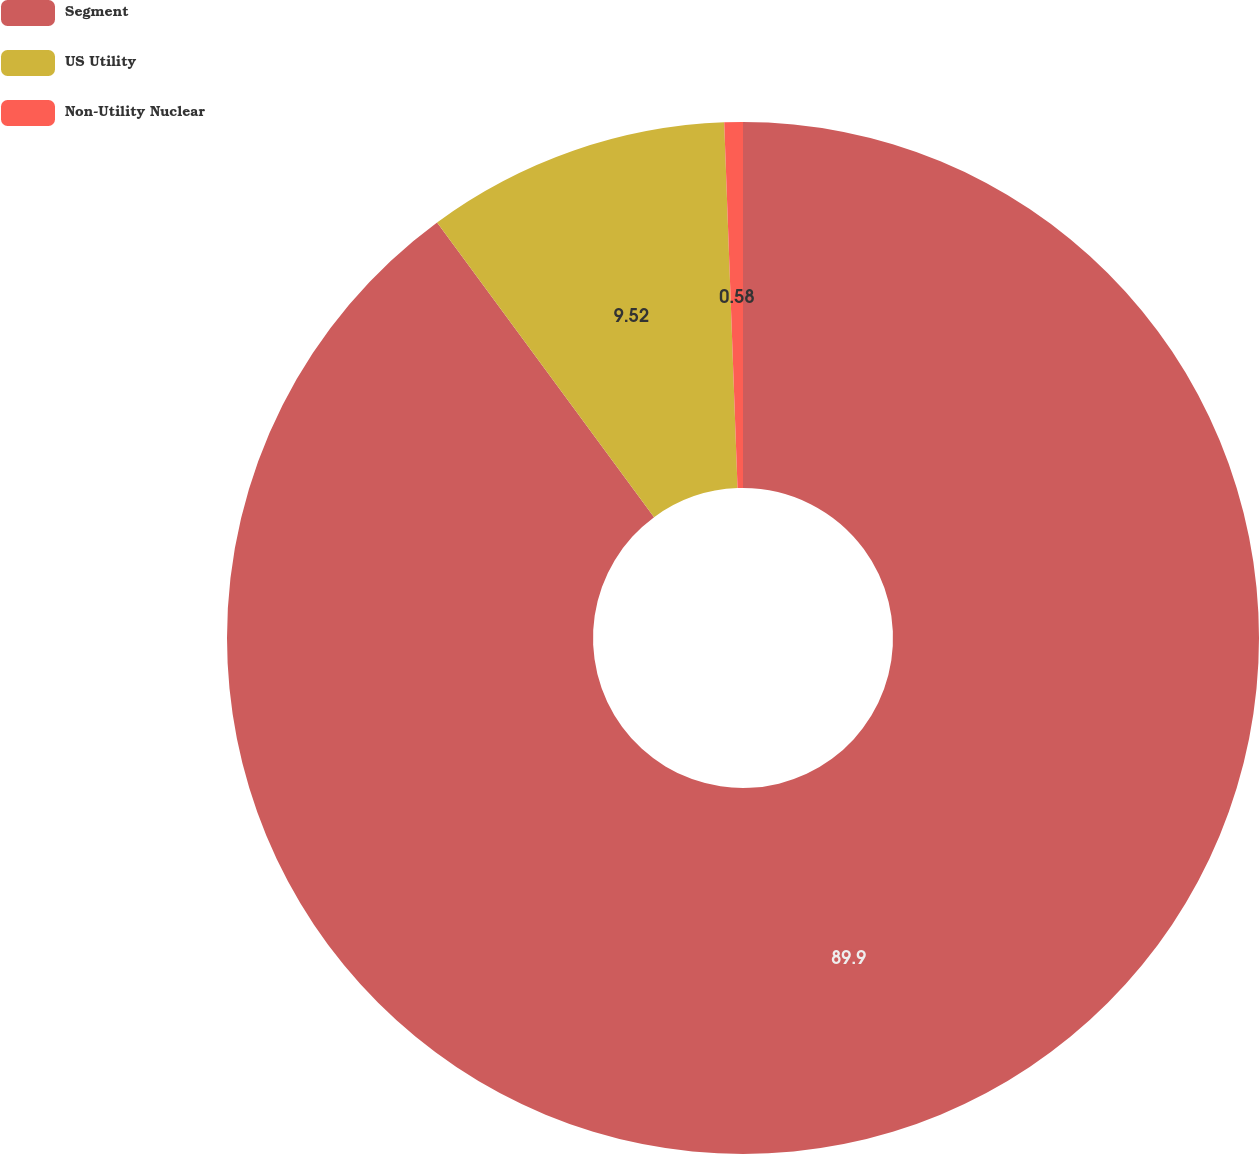Convert chart to OTSL. <chart><loc_0><loc_0><loc_500><loc_500><pie_chart><fcel>Segment<fcel>US Utility<fcel>Non-Utility Nuclear<nl><fcel>89.9%<fcel>9.52%<fcel>0.58%<nl></chart> 